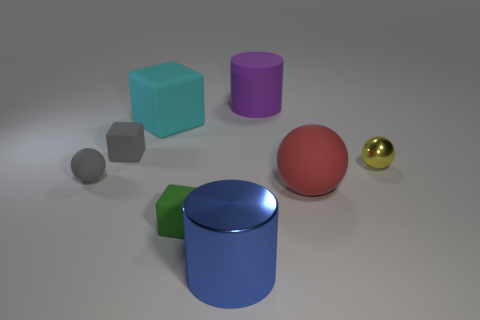There is a gray ball that is made of the same material as the cyan thing; what is its size?
Give a very brief answer. Small. What is the material of the thing that is on the right side of the green matte object and in front of the red object?
Your answer should be very brief. Metal. What number of metal balls have the same size as the green rubber object?
Your response must be concise. 1. What is the material of the blue thing that is the same shape as the large purple rubber object?
Make the answer very short. Metal. What number of objects are rubber things behind the big red object or cylinders that are right of the large blue cylinder?
Keep it short and to the point. 4. Do the purple thing and the small thing that is on the right side of the big purple object have the same shape?
Offer a terse response. No. What is the shape of the gray thing that is behind the metallic thing that is behind the small gray rubber thing that is in front of the tiny yellow metal thing?
Offer a terse response. Cube. What number of other things are the same material as the big ball?
Your answer should be very brief. 5. What number of objects are either tiny gray rubber things that are behind the metallic sphere or green matte objects?
Offer a terse response. 2. There is a large purple thing that is on the right side of the rubber sphere to the left of the gray rubber cube; what is its shape?
Give a very brief answer. Cylinder. 